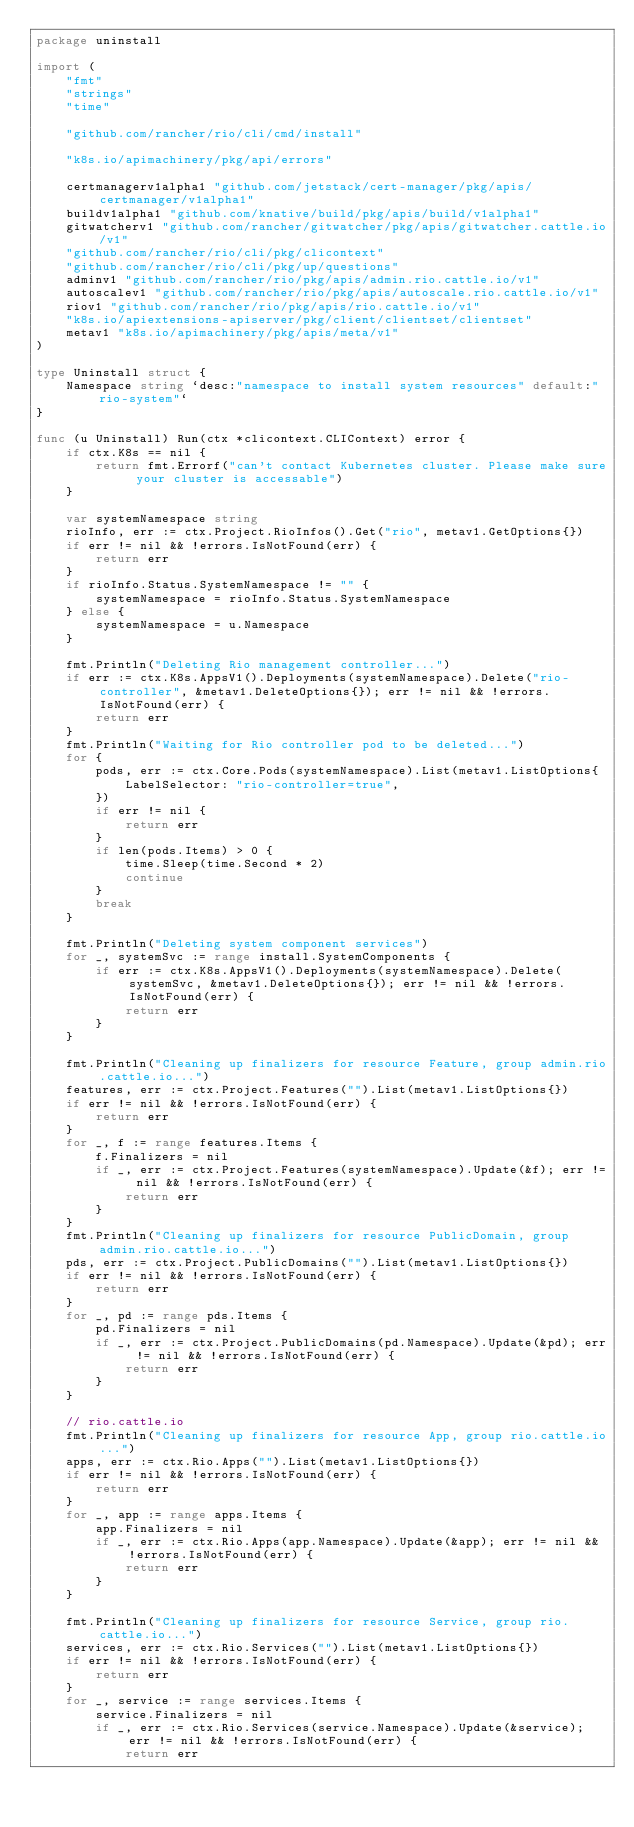<code> <loc_0><loc_0><loc_500><loc_500><_Go_>package uninstall

import (
	"fmt"
	"strings"
	"time"

	"github.com/rancher/rio/cli/cmd/install"

	"k8s.io/apimachinery/pkg/api/errors"

	certmanagerv1alpha1 "github.com/jetstack/cert-manager/pkg/apis/certmanager/v1alpha1"
	buildv1alpha1 "github.com/knative/build/pkg/apis/build/v1alpha1"
	gitwatcherv1 "github.com/rancher/gitwatcher/pkg/apis/gitwatcher.cattle.io/v1"
	"github.com/rancher/rio/cli/pkg/clicontext"
	"github.com/rancher/rio/cli/pkg/up/questions"
	adminv1 "github.com/rancher/rio/pkg/apis/admin.rio.cattle.io/v1"
	autoscalev1 "github.com/rancher/rio/pkg/apis/autoscale.rio.cattle.io/v1"
	riov1 "github.com/rancher/rio/pkg/apis/rio.cattle.io/v1"
	"k8s.io/apiextensions-apiserver/pkg/client/clientset/clientset"
	metav1 "k8s.io/apimachinery/pkg/apis/meta/v1"
)

type Uninstall struct {
	Namespace string `desc:"namespace to install system resources" default:"rio-system"`
}

func (u Uninstall) Run(ctx *clicontext.CLIContext) error {
	if ctx.K8s == nil {
		return fmt.Errorf("can't contact Kubernetes cluster. Please make sure your cluster is accessable")
	}

	var systemNamespace string
	rioInfo, err := ctx.Project.RioInfos().Get("rio", metav1.GetOptions{})
	if err != nil && !errors.IsNotFound(err) {
		return err
	}
	if rioInfo.Status.SystemNamespace != "" {
		systemNamespace = rioInfo.Status.SystemNamespace
	} else {
		systemNamespace = u.Namespace
	}

	fmt.Println("Deleting Rio management controller...")
	if err := ctx.K8s.AppsV1().Deployments(systemNamespace).Delete("rio-controller", &metav1.DeleteOptions{}); err != nil && !errors.IsNotFound(err) {
		return err
	}
	fmt.Println("Waiting for Rio controller pod to be deleted...")
	for {
		pods, err := ctx.Core.Pods(systemNamespace).List(metav1.ListOptions{
			LabelSelector: "rio-controller=true",
		})
		if err != nil {
			return err
		}
		if len(pods.Items) > 0 {
			time.Sleep(time.Second * 2)
			continue
		}
		break
	}

	fmt.Println("Deleting system component services")
	for _, systemSvc := range install.SystemComponents {
		if err := ctx.K8s.AppsV1().Deployments(systemNamespace).Delete(systemSvc, &metav1.DeleteOptions{}); err != nil && !errors.IsNotFound(err) {
			return err
		}
	}

	fmt.Println("Cleaning up finalizers for resource Feature, group admin.rio.cattle.io...")
	features, err := ctx.Project.Features("").List(metav1.ListOptions{})
	if err != nil && !errors.IsNotFound(err) {
		return err
	}
	for _, f := range features.Items {
		f.Finalizers = nil
		if _, err := ctx.Project.Features(systemNamespace).Update(&f); err != nil && !errors.IsNotFound(err) {
			return err
		}
	}
	fmt.Println("Cleaning up finalizers for resource PublicDomain, group admin.rio.cattle.io...")
	pds, err := ctx.Project.PublicDomains("").List(metav1.ListOptions{})
	if err != nil && !errors.IsNotFound(err) {
		return err
	}
	for _, pd := range pds.Items {
		pd.Finalizers = nil
		if _, err := ctx.Project.PublicDomains(pd.Namespace).Update(&pd); err != nil && !errors.IsNotFound(err) {
			return err
		}
	}

	// rio.cattle.io
	fmt.Println("Cleaning up finalizers for resource App, group rio.cattle.io...")
	apps, err := ctx.Rio.Apps("").List(metav1.ListOptions{})
	if err != nil && !errors.IsNotFound(err) {
		return err
	}
	for _, app := range apps.Items {
		app.Finalizers = nil
		if _, err := ctx.Rio.Apps(app.Namespace).Update(&app); err != nil && !errors.IsNotFound(err) {
			return err
		}
	}

	fmt.Println("Cleaning up finalizers for resource Service, group rio.cattle.io...")
	services, err := ctx.Rio.Services("").List(metav1.ListOptions{})
	if err != nil && !errors.IsNotFound(err) {
		return err
	}
	for _, service := range services.Items {
		service.Finalizers = nil
		if _, err := ctx.Rio.Services(service.Namespace).Update(&service); err != nil && !errors.IsNotFound(err) {
			return err</code> 